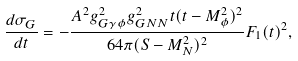Convert formula to latex. <formula><loc_0><loc_0><loc_500><loc_500>\frac { d \sigma _ { G } } { d t } = - \frac { A ^ { 2 } g _ { G \gamma \phi } ^ { 2 } g _ { G N N } ^ { 2 } t ( t - M _ { \phi } ^ { 2 } ) ^ { 2 } } { 6 4 \pi ( S - M _ { N } ^ { 2 } ) ^ { 2 } } F _ { 1 } ( t ) ^ { 2 } ,</formula> 